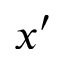<formula> <loc_0><loc_0><loc_500><loc_500>x ^ { \prime }</formula> 